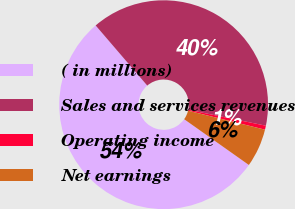Convert chart to OTSL. <chart><loc_0><loc_0><loc_500><loc_500><pie_chart><fcel>( in millions)<fcel>Sales and services revenues<fcel>Operating income<fcel>Net earnings<nl><fcel>53.92%<fcel>39.52%<fcel>0.62%<fcel>5.95%<nl></chart> 